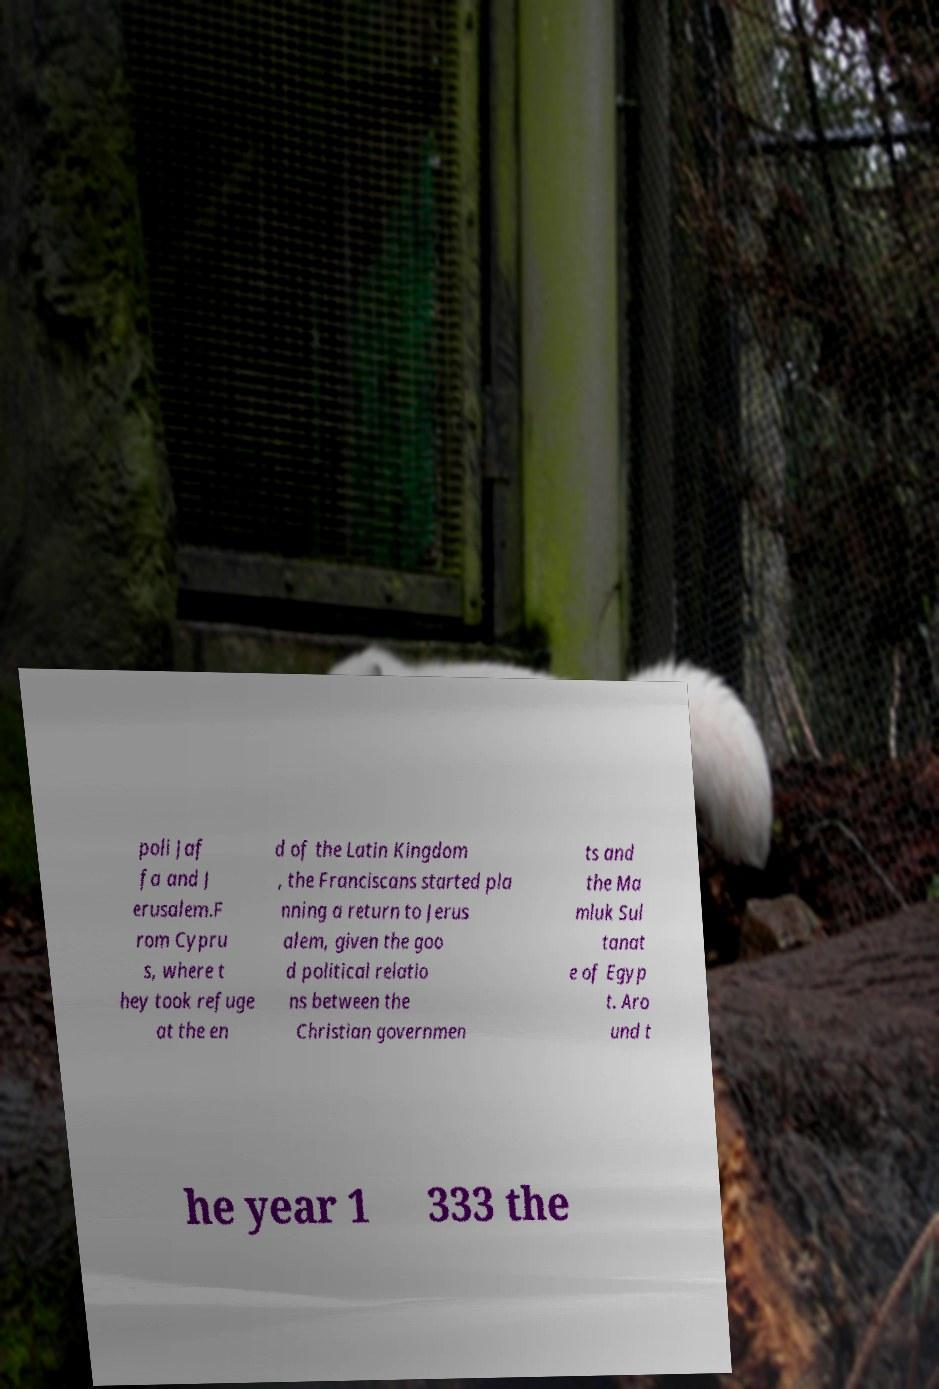Can you read and provide the text displayed in the image?This photo seems to have some interesting text. Can you extract and type it out for me? poli Jaf fa and J erusalem.F rom Cypru s, where t hey took refuge at the en d of the Latin Kingdom , the Franciscans started pla nning a return to Jerus alem, given the goo d political relatio ns between the Christian governmen ts and the Ma mluk Sul tanat e of Egyp t. Aro und t he year 1 333 the 